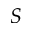Convert formula to latex. <formula><loc_0><loc_0><loc_500><loc_500>S</formula> 